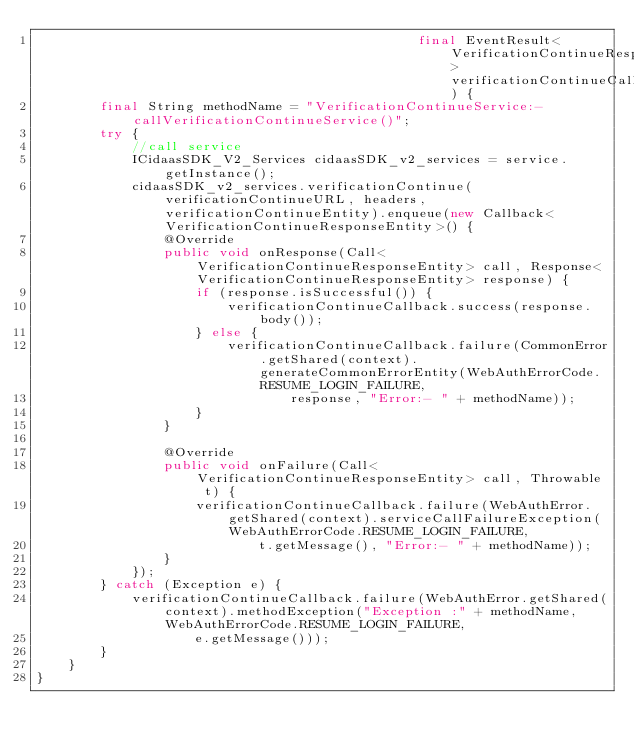Convert code to text. <code><loc_0><loc_0><loc_500><loc_500><_Java_>                                                final EventResult<VerificationContinueResponseEntity> verificationContinueCallback) {
        final String methodName = "VerificationContinueService:-callVerificationContinueService()";
        try {
            //call service
            ICidaasSDK_V2_Services cidaasSDK_v2_services = service.getInstance();
            cidaasSDK_v2_services.verificationContinue(verificationContinueURL, headers, verificationContinueEntity).enqueue(new Callback<VerificationContinueResponseEntity>() {
                @Override
                public void onResponse(Call<VerificationContinueResponseEntity> call, Response<VerificationContinueResponseEntity> response) {
                    if (response.isSuccessful()) {
                        verificationContinueCallback.success(response.body());
                    } else {
                        verificationContinueCallback.failure(CommonError.getShared(context).generateCommonErrorEntity(WebAuthErrorCode.RESUME_LOGIN_FAILURE,
                                response, "Error:- " + methodName));
                    }
                }

                @Override
                public void onFailure(Call<VerificationContinueResponseEntity> call, Throwable t) {
                    verificationContinueCallback.failure(WebAuthError.getShared(context).serviceCallFailureException(WebAuthErrorCode.RESUME_LOGIN_FAILURE,
                            t.getMessage(), "Error:- " + methodName));
                }
            });
        } catch (Exception e) {
            verificationContinueCallback.failure(WebAuthError.getShared(context).methodException("Exception :" + methodName, WebAuthErrorCode.RESUME_LOGIN_FAILURE,
                    e.getMessage()));
        }
    }
}</code> 